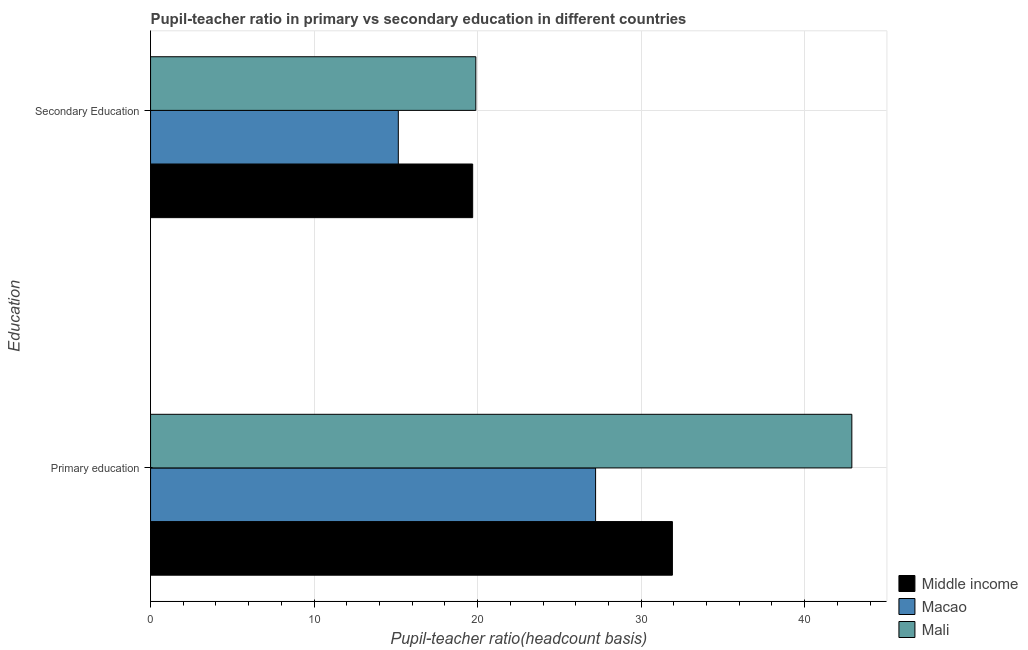Are the number of bars on each tick of the Y-axis equal?
Offer a very short reply. Yes. What is the label of the 2nd group of bars from the top?
Provide a succinct answer. Primary education. What is the pupil-teacher ratio in primary education in Mali?
Your answer should be compact. 42.88. Across all countries, what is the maximum pupil-teacher ratio in primary education?
Keep it short and to the point. 42.88. Across all countries, what is the minimum pupil-teacher ratio in primary education?
Your response must be concise. 27.21. In which country was the pupil teacher ratio on secondary education maximum?
Ensure brevity in your answer.  Mali. In which country was the pupil-teacher ratio in primary education minimum?
Make the answer very short. Macao. What is the total pupil-teacher ratio in primary education in the graph?
Provide a succinct answer. 102.01. What is the difference between the pupil teacher ratio on secondary education in Macao and that in Middle income?
Give a very brief answer. -4.55. What is the difference between the pupil teacher ratio on secondary education in Macao and the pupil-teacher ratio in primary education in Middle income?
Make the answer very short. -16.76. What is the average pupil-teacher ratio in primary education per country?
Provide a succinct answer. 34. What is the difference between the pupil-teacher ratio in primary education and pupil teacher ratio on secondary education in Mali?
Provide a short and direct response. 22.99. In how many countries, is the pupil teacher ratio on secondary education greater than 2 ?
Your response must be concise. 3. What is the ratio of the pupil-teacher ratio in primary education in Mali to that in Middle income?
Provide a succinct answer. 1.34. Is the pupil teacher ratio on secondary education in Middle income less than that in Mali?
Provide a succinct answer. Yes. In how many countries, is the pupil teacher ratio on secondary education greater than the average pupil teacher ratio on secondary education taken over all countries?
Make the answer very short. 2. What does the 1st bar from the top in Primary education represents?
Keep it short and to the point. Mali. Are all the bars in the graph horizontal?
Keep it short and to the point. Yes. How many countries are there in the graph?
Ensure brevity in your answer.  3. Does the graph contain any zero values?
Give a very brief answer. No. Does the graph contain grids?
Provide a succinct answer. Yes. What is the title of the graph?
Your answer should be compact. Pupil-teacher ratio in primary vs secondary education in different countries. What is the label or title of the X-axis?
Provide a short and direct response. Pupil-teacher ratio(headcount basis). What is the label or title of the Y-axis?
Your answer should be compact. Education. What is the Pupil-teacher ratio(headcount basis) in Middle income in Primary education?
Make the answer very short. 31.91. What is the Pupil-teacher ratio(headcount basis) in Macao in Primary education?
Provide a short and direct response. 27.21. What is the Pupil-teacher ratio(headcount basis) of Mali in Primary education?
Your answer should be very brief. 42.88. What is the Pupil-teacher ratio(headcount basis) in Middle income in Secondary Education?
Keep it short and to the point. 19.7. What is the Pupil-teacher ratio(headcount basis) in Macao in Secondary Education?
Keep it short and to the point. 15.15. What is the Pupil-teacher ratio(headcount basis) of Mali in Secondary Education?
Provide a short and direct response. 19.89. Across all Education, what is the maximum Pupil-teacher ratio(headcount basis) of Middle income?
Make the answer very short. 31.91. Across all Education, what is the maximum Pupil-teacher ratio(headcount basis) of Macao?
Ensure brevity in your answer.  27.21. Across all Education, what is the maximum Pupil-teacher ratio(headcount basis) of Mali?
Your response must be concise. 42.88. Across all Education, what is the minimum Pupil-teacher ratio(headcount basis) in Middle income?
Your answer should be very brief. 19.7. Across all Education, what is the minimum Pupil-teacher ratio(headcount basis) in Macao?
Give a very brief answer. 15.15. Across all Education, what is the minimum Pupil-teacher ratio(headcount basis) of Mali?
Your answer should be compact. 19.89. What is the total Pupil-teacher ratio(headcount basis) in Middle income in the graph?
Keep it short and to the point. 51.61. What is the total Pupil-teacher ratio(headcount basis) of Macao in the graph?
Offer a terse response. 42.36. What is the total Pupil-teacher ratio(headcount basis) of Mali in the graph?
Your response must be concise. 62.77. What is the difference between the Pupil-teacher ratio(headcount basis) in Middle income in Primary education and that in Secondary Education?
Offer a terse response. 12.21. What is the difference between the Pupil-teacher ratio(headcount basis) in Macao in Primary education and that in Secondary Education?
Your answer should be very brief. 12.06. What is the difference between the Pupil-teacher ratio(headcount basis) in Mali in Primary education and that in Secondary Education?
Ensure brevity in your answer.  22.99. What is the difference between the Pupil-teacher ratio(headcount basis) in Middle income in Primary education and the Pupil-teacher ratio(headcount basis) in Macao in Secondary Education?
Make the answer very short. 16.76. What is the difference between the Pupil-teacher ratio(headcount basis) of Middle income in Primary education and the Pupil-teacher ratio(headcount basis) of Mali in Secondary Education?
Keep it short and to the point. 12.02. What is the difference between the Pupil-teacher ratio(headcount basis) in Macao in Primary education and the Pupil-teacher ratio(headcount basis) in Mali in Secondary Education?
Provide a succinct answer. 7.32. What is the average Pupil-teacher ratio(headcount basis) in Middle income per Education?
Offer a terse response. 25.8. What is the average Pupil-teacher ratio(headcount basis) in Macao per Education?
Your response must be concise. 21.18. What is the average Pupil-teacher ratio(headcount basis) in Mali per Education?
Your answer should be very brief. 31.39. What is the difference between the Pupil-teacher ratio(headcount basis) of Middle income and Pupil-teacher ratio(headcount basis) of Macao in Primary education?
Provide a succinct answer. 4.7. What is the difference between the Pupil-teacher ratio(headcount basis) in Middle income and Pupil-teacher ratio(headcount basis) in Mali in Primary education?
Your response must be concise. -10.97. What is the difference between the Pupil-teacher ratio(headcount basis) in Macao and Pupil-teacher ratio(headcount basis) in Mali in Primary education?
Ensure brevity in your answer.  -15.67. What is the difference between the Pupil-teacher ratio(headcount basis) of Middle income and Pupil-teacher ratio(headcount basis) of Macao in Secondary Education?
Ensure brevity in your answer.  4.55. What is the difference between the Pupil-teacher ratio(headcount basis) of Middle income and Pupil-teacher ratio(headcount basis) of Mali in Secondary Education?
Your answer should be very brief. -0.19. What is the difference between the Pupil-teacher ratio(headcount basis) of Macao and Pupil-teacher ratio(headcount basis) of Mali in Secondary Education?
Your answer should be compact. -4.74. What is the ratio of the Pupil-teacher ratio(headcount basis) of Middle income in Primary education to that in Secondary Education?
Keep it short and to the point. 1.62. What is the ratio of the Pupil-teacher ratio(headcount basis) of Macao in Primary education to that in Secondary Education?
Your answer should be very brief. 1.8. What is the ratio of the Pupil-teacher ratio(headcount basis) in Mali in Primary education to that in Secondary Education?
Offer a terse response. 2.16. What is the difference between the highest and the second highest Pupil-teacher ratio(headcount basis) in Middle income?
Offer a terse response. 12.21. What is the difference between the highest and the second highest Pupil-teacher ratio(headcount basis) of Macao?
Give a very brief answer. 12.06. What is the difference between the highest and the second highest Pupil-teacher ratio(headcount basis) of Mali?
Your response must be concise. 22.99. What is the difference between the highest and the lowest Pupil-teacher ratio(headcount basis) of Middle income?
Your response must be concise. 12.21. What is the difference between the highest and the lowest Pupil-teacher ratio(headcount basis) in Macao?
Give a very brief answer. 12.06. What is the difference between the highest and the lowest Pupil-teacher ratio(headcount basis) in Mali?
Provide a succinct answer. 22.99. 